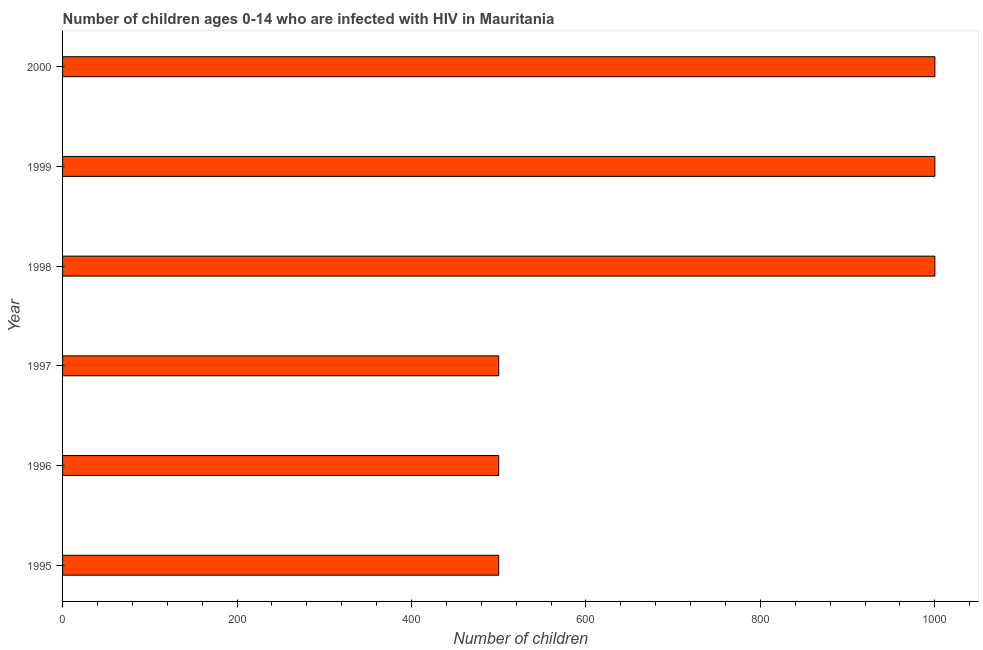Does the graph contain any zero values?
Offer a terse response. No. Does the graph contain grids?
Ensure brevity in your answer.  No. What is the title of the graph?
Your response must be concise. Number of children ages 0-14 who are infected with HIV in Mauritania. What is the label or title of the X-axis?
Give a very brief answer. Number of children. What is the label or title of the Y-axis?
Provide a short and direct response. Year. What is the sum of the number of children living with hiv?
Offer a terse response. 4500. What is the difference between the number of children living with hiv in 1998 and 1999?
Your answer should be compact. 0. What is the average number of children living with hiv per year?
Offer a terse response. 750. What is the median number of children living with hiv?
Your answer should be very brief. 750. Is the number of children living with hiv in 1995 less than that in 2000?
Give a very brief answer. Yes. Is the difference between the number of children living with hiv in 1998 and 1999 greater than the difference between any two years?
Your answer should be very brief. No. What is the difference between the highest and the second highest number of children living with hiv?
Make the answer very short. 0. What is the difference between the highest and the lowest number of children living with hiv?
Ensure brevity in your answer.  500. Are all the bars in the graph horizontal?
Offer a very short reply. Yes. What is the Number of children of 1997?
Make the answer very short. 500. What is the Number of children in 1998?
Ensure brevity in your answer.  1000. What is the Number of children of 1999?
Provide a succinct answer. 1000. What is the Number of children of 2000?
Keep it short and to the point. 1000. What is the difference between the Number of children in 1995 and 1996?
Ensure brevity in your answer.  0. What is the difference between the Number of children in 1995 and 1998?
Provide a succinct answer. -500. What is the difference between the Number of children in 1995 and 1999?
Offer a very short reply. -500. What is the difference between the Number of children in 1995 and 2000?
Provide a succinct answer. -500. What is the difference between the Number of children in 1996 and 1998?
Your response must be concise. -500. What is the difference between the Number of children in 1996 and 1999?
Your answer should be very brief. -500. What is the difference between the Number of children in 1996 and 2000?
Provide a succinct answer. -500. What is the difference between the Number of children in 1997 and 1998?
Give a very brief answer. -500. What is the difference between the Number of children in 1997 and 1999?
Give a very brief answer. -500. What is the difference between the Number of children in 1997 and 2000?
Provide a succinct answer. -500. What is the ratio of the Number of children in 1995 to that in 1999?
Your answer should be very brief. 0.5. What is the ratio of the Number of children in 1995 to that in 2000?
Offer a terse response. 0.5. What is the ratio of the Number of children in 1996 to that in 1997?
Your answer should be compact. 1. What is the ratio of the Number of children in 1996 to that in 1998?
Ensure brevity in your answer.  0.5. What is the ratio of the Number of children in 1996 to that in 2000?
Offer a terse response. 0.5. What is the ratio of the Number of children in 1997 to that in 1998?
Give a very brief answer. 0.5. What is the ratio of the Number of children in 1997 to that in 1999?
Keep it short and to the point. 0.5. What is the ratio of the Number of children in 1997 to that in 2000?
Provide a short and direct response. 0.5. 